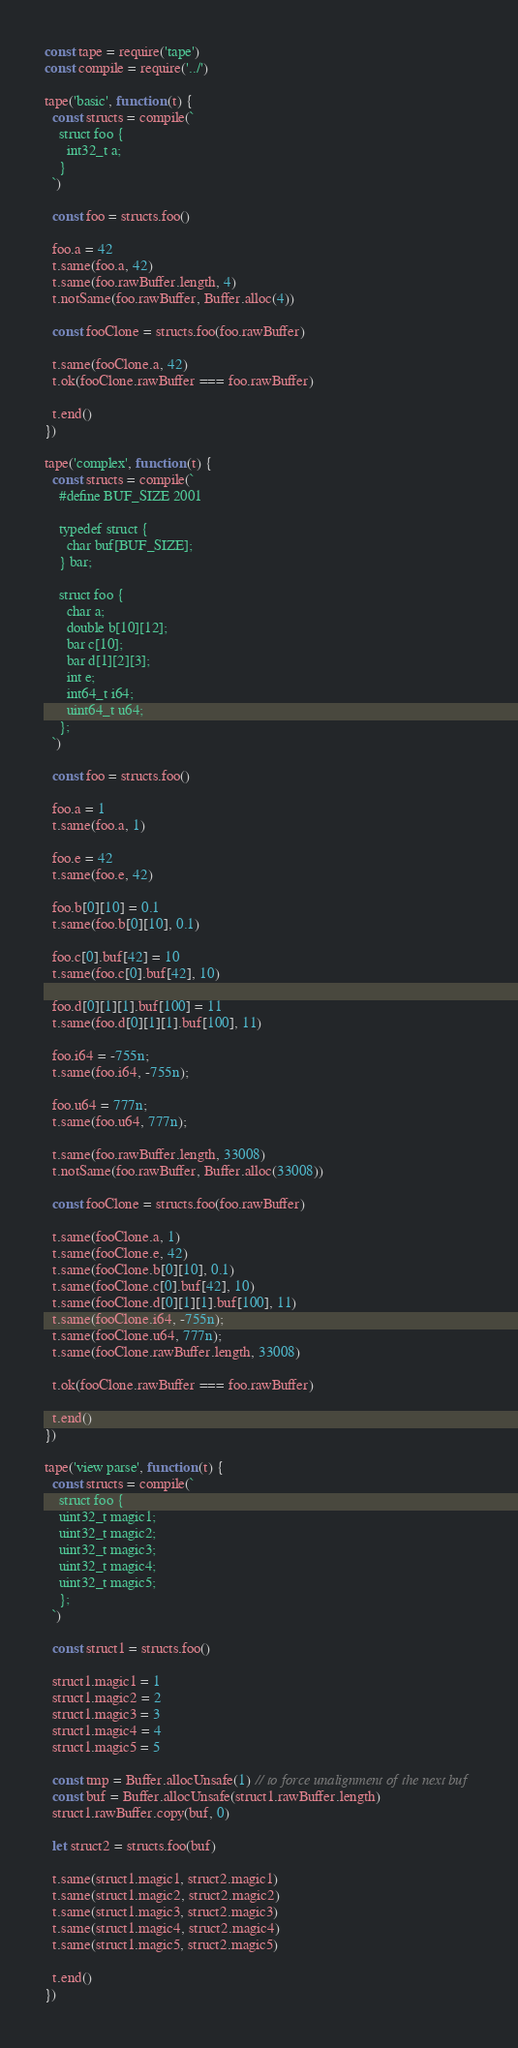<code> <loc_0><loc_0><loc_500><loc_500><_JavaScript_>const tape = require('tape')
const compile = require('../')

tape('basic', function (t) {
  const structs = compile(`
    struct foo {
      int32_t a;
    }
  `)

  const foo = structs.foo()

  foo.a = 42
  t.same(foo.a, 42)
  t.same(foo.rawBuffer.length, 4)
  t.notSame(foo.rawBuffer, Buffer.alloc(4))

  const fooClone = structs.foo(foo.rawBuffer)

  t.same(fooClone.a, 42)
  t.ok(fooClone.rawBuffer === foo.rawBuffer)

  t.end()
})

tape('complex', function (t) {
  const structs = compile(`
    #define BUF_SIZE 2001

    typedef struct {
      char buf[BUF_SIZE];
    } bar;

    struct foo {
      char a;
      double b[10][12];
      bar c[10];
      bar d[1][2][3];
      int e;
      int64_t i64;
      uint64_t u64;
    };
  `)

  const foo = structs.foo()

  foo.a = 1
  t.same(foo.a, 1)

  foo.e = 42
  t.same(foo.e, 42)

  foo.b[0][10] = 0.1
  t.same(foo.b[0][10], 0.1)

  foo.c[0].buf[42] = 10
  t.same(foo.c[0].buf[42], 10)

  foo.d[0][1][1].buf[100] = 11
  t.same(foo.d[0][1][1].buf[100], 11)

  foo.i64 = -755n;
  t.same(foo.i64, -755n);

  foo.u64 = 777n;
  t.same(foo.u64, 777n);

  t.same(foo.rawBuffer.length, 33008)
  t.notSame(foo.rawBuffer, Buffer.alloc(33008))

  const fooClone = structs.foo(foo.rawBuffer)

  t.same(fooClone.a, 1)
  t.same(fooClone.e, 42)
  t.same(fooClone.b[0][10], 0.1)
  t.same(fooClone.c[0].buf[42], 10)
  t.same(fooClone.d[0][1][1].buf[100], 11)
  t.same(fooClone.i64, -755n);
  t.same(fooClone.u64, 777n);
  t.same(fooClone.rawBuffer.length, 33008)

  t.ok(fooClone.rawBuffer === foo.rawBuffer)

  t.end()
})

tape('view parse', function (t) {
  const structs = compile(`
    struct foo {
    uint32_t magic1;
    uint32_t magic2;
    uint32_t magic3;
    uint32_t magic4;
    uint32_t magic5;
    };
  `)

  const struct1 = structs.foo()

  struct1.magic1 = 1
  struct1.magic2 = 2
  struct1.magic3 = 3
  struct1.magic4 = 4
  struct1.magic5 = 5

  const tmp = Buffer.allocUnsafe(1) // to force unalignment of the next buf
  const buf = Buffer.allocUnsafe(struct1.rawBuffer.length)
  struct1.rawBuffer.copy(buf, 0)

  let struct2 = structs.foo(buf)

  t.same(struct1.magic1, struct2.magic1)
  t.same(struct1.magic2, struct2.magic2)
  t.same(struct1.magic3, struct2.magic3)
  t.same(struct1.magic4, struct2.magic4)
  t.same(struct1.magic5, struct2.magic5)

  t.end()
})
</code> 